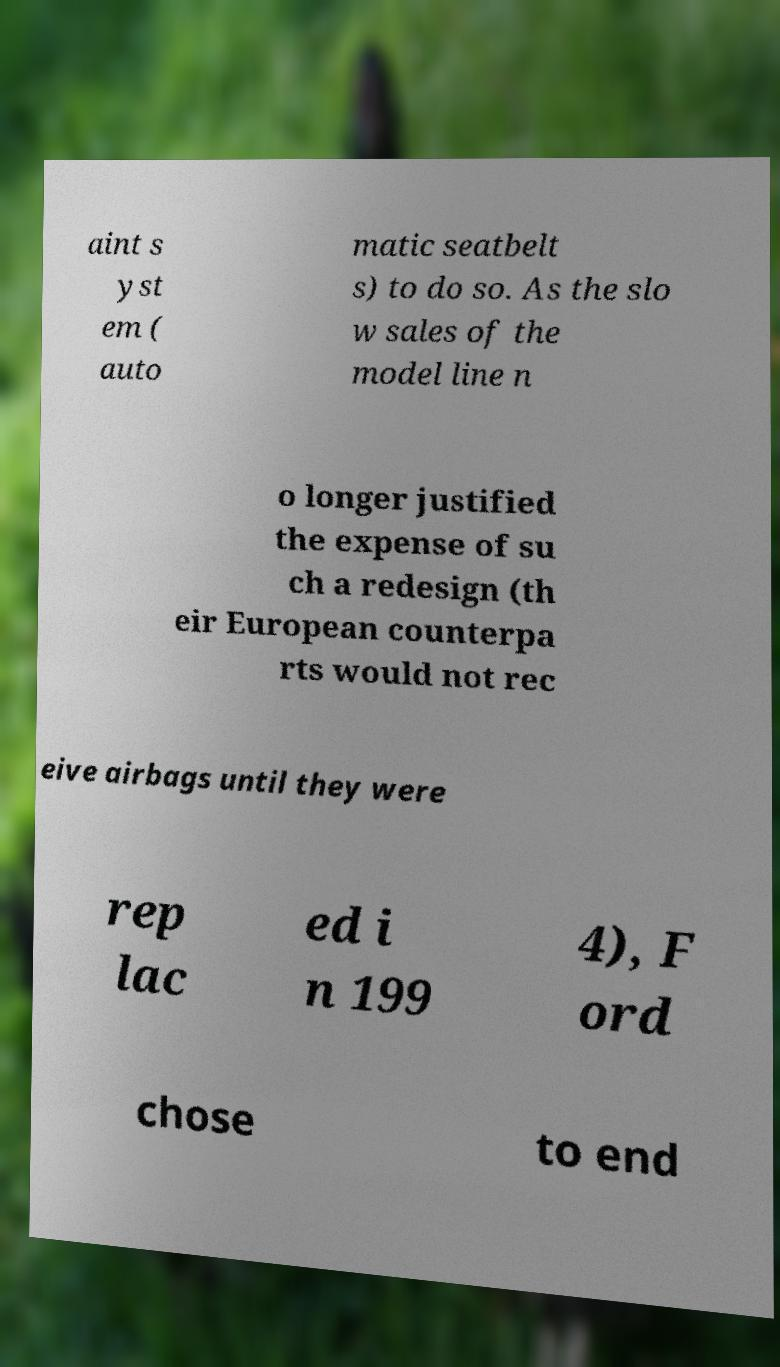Could you extract and type out the text from this image? aint s yst em ( auto matic seatbelt s) to do so. As the slo w sales of the model line n o longer justified the expense of su ch a redesign (th eir European counterpa rts would not rec eive airbags until they were rep lac ed i n 199 4), F ord chose to end 